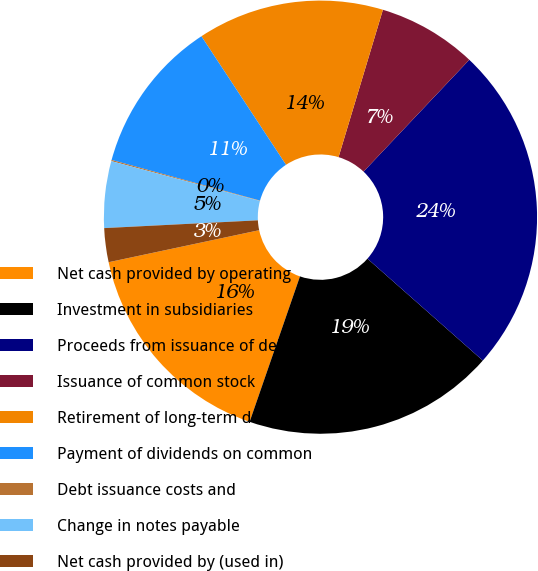Convert chart. <chart><loc_0><loc_0><loc_500><loc_500><pie_chart><fcel>Net cash provided by operating<fcel>Investment in subsidiaries<fcel>Proceeds from issuance of debt<fcel>Issuance of common stock<fcel>Retirement of long-term debt<fcel>Payment of dividends on common<fcel>Debt issuance costs and<fcel>Change in notes payable<fcel>Net cash provided by (used in)<nl><fcel>16.36%<fcel>18.79%<fcel>24.46%<fcel>7.4%<fcel>13.92%<fcel>11.48%<fcel>0.09%<fcel>4.97%<fcel>2.53%<nl></chart> 